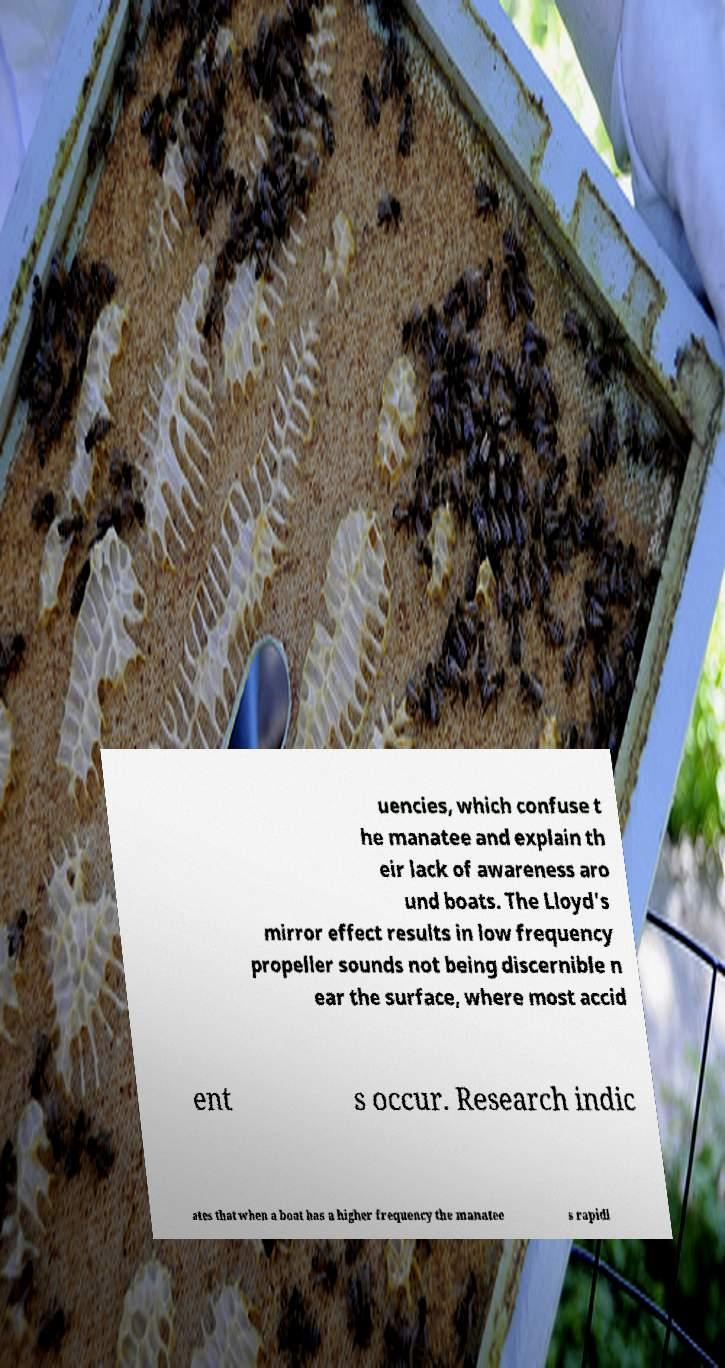There's text embedded in this image that I need extracted. Can you transcribe it verbatim? uencies, which confuse t he manatee and explain th eir lack of awareness aro und boats. The Lloyd's mirror effect results in low frequency propeller sounds not being discernible n ear the surface, where most accid ent s occur. Research indic ates that when a boat has a higher frequency the manatee s rapidl 